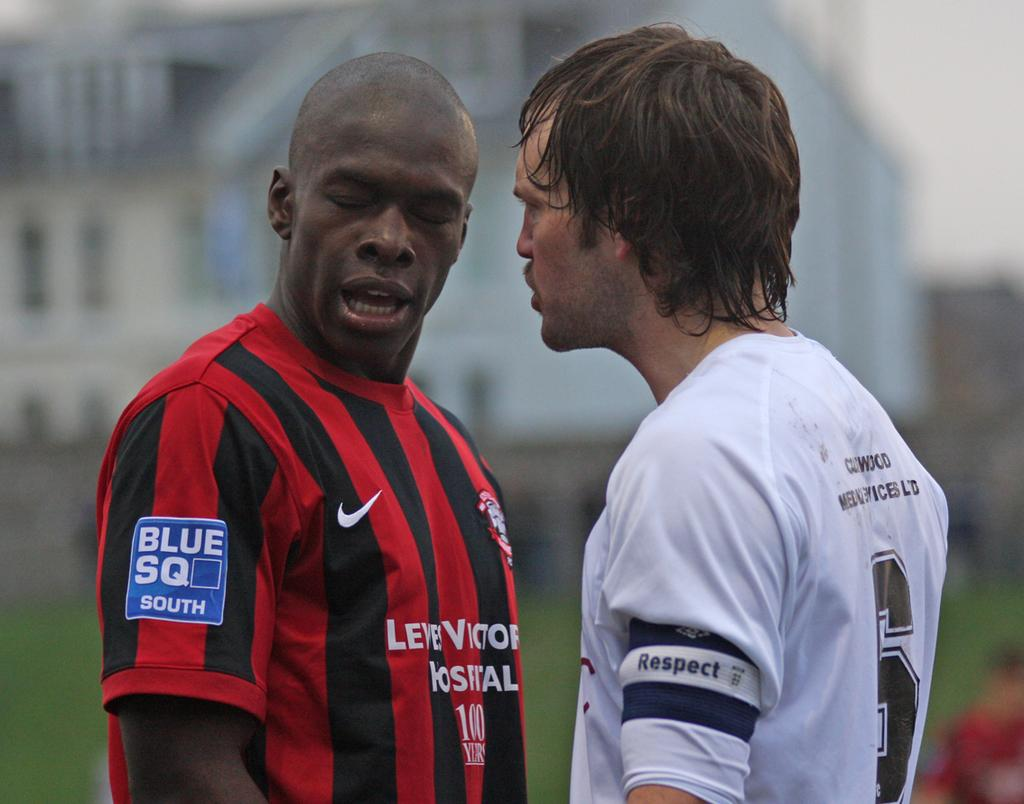Provide a one-sentence caption for the provided image. Two soccer players facing each other with one shirt saying Blue SQ South. 